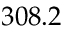<formula> <loc_0><loc_0><loc_500><loc_500>3 0 8 . 2</formula> 